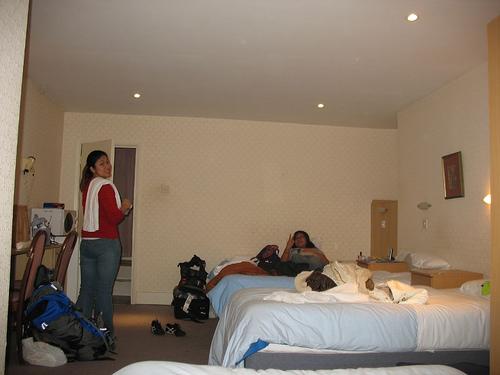What color towel does the woman have over her right shoulder?
Keep it brief. White. How many beds are in the room?
Quick response, please. 2. Is this a hotel room?
Quick response, please. Yes. 